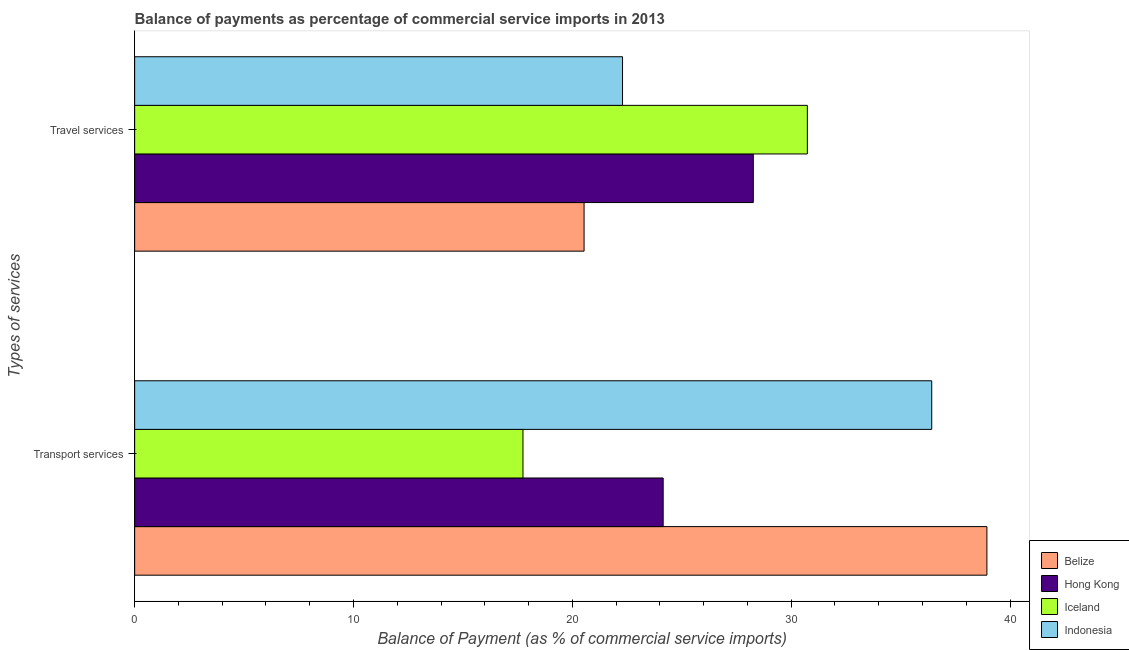How many groups of bars are there?
Your answer should be compact. 2. Are the number of bars on each tick of the Y-axis equal?
Your answer should be very brief. Yes. What is the label of the 2nd group of bars from the top?
Provide a short and direct response. Transport services. What is the balance of payments of travel services in Belize?
Offer a terse response. 20.54. Across all countries, what is the maximum balance of payments of travel services?
Your answer should be very brief. 30.74. Across all countries, what is the minimum balance of payments of travel services?
Your answer should be compact. 20.54. In which country was the balance of payments of transport services maximum?
Your answer should be very brief. Belize. In which country was the balance of payments of travel services minimum?
Offer a terse response. Belize. What is the total balance of payments of transport services in the graph?
Your response must be concise. 117.26. What is the difference between the balance of payments of travel services in Belize and that in Indonesia?
Offer a very short reply. -1.76. What is the difference between the balance of payments of travel services in Iceland and the balance of payments of transport services in Belize?
Offer a terse response. -8.2. What is the average balance of payments of transport services per country?
Offer a very short reply. 29.32. What is the difference between the balance of payments of transport services and balance of payments of travel services in Indonesia?
Your response must be concise. 14.13. What is the ratio of the balance of payments of travel services in Indonesia to that in Belize?
Your response must be concise. 1.09. What does the 2nd bar from the top in Transport services represents?
Your answer should be very brief. Iceland. Are all the bars in the graph horizontal?
Ensure brevity in your answer.  Yes. What is the difference between two consecutive major ticks on the X-axis?
Give a very brief answer. 10. How many legend labels are there?
Your answer should be compact. 4. What is the title of the graph?
Make the answer very short. Balance of payments as percentage of commercial service imports in 2013. What is the label or title of the X-axis?
Your answer should be compact. Balance of Payment (as % of commercial service imports). What is the label or title of the Y-axis?
Offer a terse response. Types of services. What is the Balance of Payment (as % of commercial service imports) of Belize in Transport services?
Provide a succinct answer. 38.94. What is the Balance of Payment (as % of commercial service imports) of Hong Kong in Transport services?
Ensure brevity in your answer.  24.15. What is the Balance of Payment (as % of commercial service imports) in Iceland in Transport services?
Offer a very short reply. 17.75. What is the Balance of Payment (as % of commercial service imports) of Indonesia in Transport services?
Your response must be concise. 36.42. What is the Balance of Payment (as % of commercial service imports) in Belize in Travel services?
Give a very brief answer. 20.54. What is the Balance of Payment (as % of commercial service imports) of Hong Kong in Travel services?
Make the answer very short. 28.27. What is the Balance of Payment (as % of commercial service imports) in Iceland in Travel services?
Your answer should be compact. 30.74. What is the Balance of Payment (as % of commercial service imports) of Indonesia in Travel services?
Provide a short and direct response. 22.29. Across all Types of services, what is the maximum Balance of Payment (as % of commercial service imports) in Belize?
Keep it short and to the point. 38.94. Across all Types of services, what is the maximum Balance of Payment (as % of commercial service imports) in Hong Kong?
Provide a short and direct response. 28.27. Across all Types of services, what is the maximum Balance of Payment (as % of commercial service imports) of Iceland?
Keep it short and to the point. 30.74. Across all Types of services, what is the maximum Balance of Payment (as % of commercial service imports) in Indonesia?
Ensure brevity in your answer.  36.42. Across all Types of services, what is the minimum Balance of Payment (as % of commercial service imports) of Belize?
Ensure brevity in your answer.  20.54. Across all Types of services, what is the minimum Balance of Payment (as % of commercial service imports) of Hong Kong?
Give a very brief answer. 24.15. Across all Types of services, what is the minimum Balance of Payment (as % of commercial service imports) of Iceland?
Give a very brief answer. 17.75. Across all Types of services, what is the minimum Balance of Payment (as % of commercial service imports) in Indonesia?
Offer a very short reply. 22.29. What is the total Balance of Payment (as % of commercial service imports) in Belize in the graph?
Make the answer very short. 59.48. What is the total Balance of Payment (as % of commercial service imports) in Hong Kong in the graph?
Your answer should be compact. 52.42. What is the total Balance of Payment (as % of commercial service imports) of Iceland in the graph?
Make the answer very short. 48.49. What is the total Balance of Payment (as % of commercial service imports) of Indonesia in the graph?
Ensure brevity in your answer.  58.72. What is the difference between the Balance of Payment (as % of commercial service imports) in Belize in Transport services and that in Travel services?
Provide a succinct answer. 18.41. What is the difference between the Balance of Payment (as % of commercial service imports) in Hong Kong in Transport services and that in Travel services?
Make the answer very short. -4.12. What is the difference between the Balance of Payment (as % of commercial service imports) in Iceland in Transport services and that in Travel services?
Offer a very short reply. -12.99. What is the difference between the Balance of Payment (as % of commercial service imports) in Indonesia in Transport services and that in Travel services?
Ensure brevity in your answer.  14.13. What is the difference between the Balance of Payment (as % of commercial service imports) in Belize in Transport services and the Balance of Payment (as % of commercial service imports) in Hong Kong in Travel services?
Give a very brief answer. 10.67. What is the difference between the Balance of Payment (as % of commercial service imports) in Belize in Transport services and the Balance of Payment (as % of commercial service imports) in Iceland in Travel services?
Provide a succinct answer. 8.2. What is the difference between the Balance of Payment (as % of commercial service imports) of Belize in Transport services and the Balance of Payment (as % of commercial service imports) of Indonesia in Travel services?
Give a very brief answer. 16.65. What is the difference between the Balance of Payment (as % of commercial service imports) of Hong Kong in Transport services and the Balance of Payment (as % of commercial service imports) of Iceland in Travel services?
Your answer should be very brief. -6.59. What is the difference between the Balance of Payment (as % of commercial service imports) in Hong Kong in Transport services and the Balance of Payment (as % of commercial service imports) in Indonesia in Travel services?
Your answer should be very brief. 1.86. What is the difference between the Balance of Payment (as % of commercial service imports) in Iceland in Transport services and the Balance of Payment (as % of commercial service imports) in Indonesia in Travel services?
Provide a short and direct response. -4.55. What is the average Balance of Payment (as % of commercial service imports) in Belize per Types of services?
Ensure brevity in your answer.  29.74. What is the average Balance of Payment (as % of commercial service imports) in Hong Kong per Types of services?
Provide a short and direct response. 26.21. What is the average Balance of Payment (as % of commercial service imports) in Iceland per Types of services?
Make the answer very short. 24.24. What is the average Balance of Payment (as % of commercial service imports) of Indonesia per Types of services?
Your response must be concise. 29.36. What is the difference between the Balance of Payment (as % of commercial service imports) in Belize and Balance of Payment (as % of commercial service imports) in Hong Kong in Transport services?
Your answer should be very brief. 14.79. What is the difference between the Balance of Payment (as % of commercial service imports) of Belize and Balance of Payment (as % of commercial service imports) of Iceland in Transport services?
Offer a very short reply. 21.2. What is the difference between the Balance of Payment (as % of commercial service imports) of Belize and Balance of Payment (as % of commercial service imports) of Indonesia in Transport services?
Your response must be concise. 2.52. What is the difference between the Balance of Payment (as % of commercial service imports) in Hong Kong and Balance of Payment (as % of commercial service imports) in Iceland in Transport services?
Offer a terse response. 6.41. What is the difference between the Balance of Payment (as % of commercial service imports) in Hong Kong and Balance of Payment (as % of commercial service imports) in Indonesia in Transport services?
Provide a short and direct response. -12.27. What is the difference between the Balance of Payment (as % of commercial service imports) in Iceland and Balance of Payment (as % of commercial service imports) in Indonesia in Transport services?
Give a very brief answer. -18.68. What is the difference between the Balance of Payment (as % of commercial service imports) in Belize and Balance of Payment (as % of commercial service imports) in Hong Kong in Travel services?
Ensure brevity in your answer.  -7.73. What is the difference between the Balance of Payment (as % of commercial service imports) in Belize and Balance of Payment (as % of commercial service imports) in Iceland in Travel services?
Your answer should be very brief. -10.2. What is the difference between the Balance of Payment (as % of commercial service imports) in Belize and Balance of Payment (as % of commercial service imports) in Indonesia in Travel services?
Provide a short and direct response. -1.76. What is the difference between the Balance of Payment (as % of commercial service imports) of Hong Kong and Balance of Payment (as % of commercial service imports) of Iceland in Travel services?
Make the answer very short. -2.47. What is the difference between the Balance of Payment (as % of commercial service imports) in Hong Kong and Balance of Payment (as % of commercial service imports) in Indonesia in Travel services?
Make the answer very short. 5.98. What is the difference between the Balance of Payment (as % of commercial service imports) in Iceland and Balance of Payment (as % of commercial service imports) in Indonesia in Travel services?
Keep it short and to the point. 8.45. What is the ratio of the Balance of Payment (as % of commercial service imports) in Belize in Transport services to that in Travel services?
Your answer should be compact. 1.9. What is the ratio of the Balance of Payment (as % of commercial service imports) of Hong Kong in Transport services to that in Travel services?
Make the answer very short. 0.85. What is the ratio of the Balance of Payment (as % of commercial service imports) in Iceland in Transport services to that in Travel services?
Your response must be concise. 0.58. What is the ratio of the Balance of Payment (as % of commercial service imports) in Indonesia in Transport services to that in Travel services?
Ensure brevity in your answer.  1.63. What is the difference between the highest and the second highest Balance of Payment (as % of commercial service imports) of Belize?
Keep it short and to the point. 18.41. What is the difference between the highest and the second highest Balance of Payment (as % of commercial service imports) of Hong Kong?
Keep it short and to the point. 4.12. What is the difference between the highest and the second highest Balance of Payment (as % of commercial service imports) in Iceland?
Keep it short and to the point. 12.99. What is the difference between the highest and the second highest Balance of Payment (as % of commercial service imports) in Indonesia?
Offer a very short reply. 14.13. What is the difference between the highest and the lowest Balance of Payment (as % of commercial service imports) in Belize?
Your answer should be very brief. 18.41. What is the difference between the highest and the lowest Balance of Payment (as % of commercial service imports) in Hong Kong?
Provide a succinct answer. 4.12. What is the difference between the highest and the lowest Balance of Payment (as % of commercial service imports) in Iceland?
Your answer should be compact. 12.99. What is the difference between the highest and the lowest Balance of Payment (as % of commercial service imports) of Indonesia?
Make the answer very short. 14.13. 